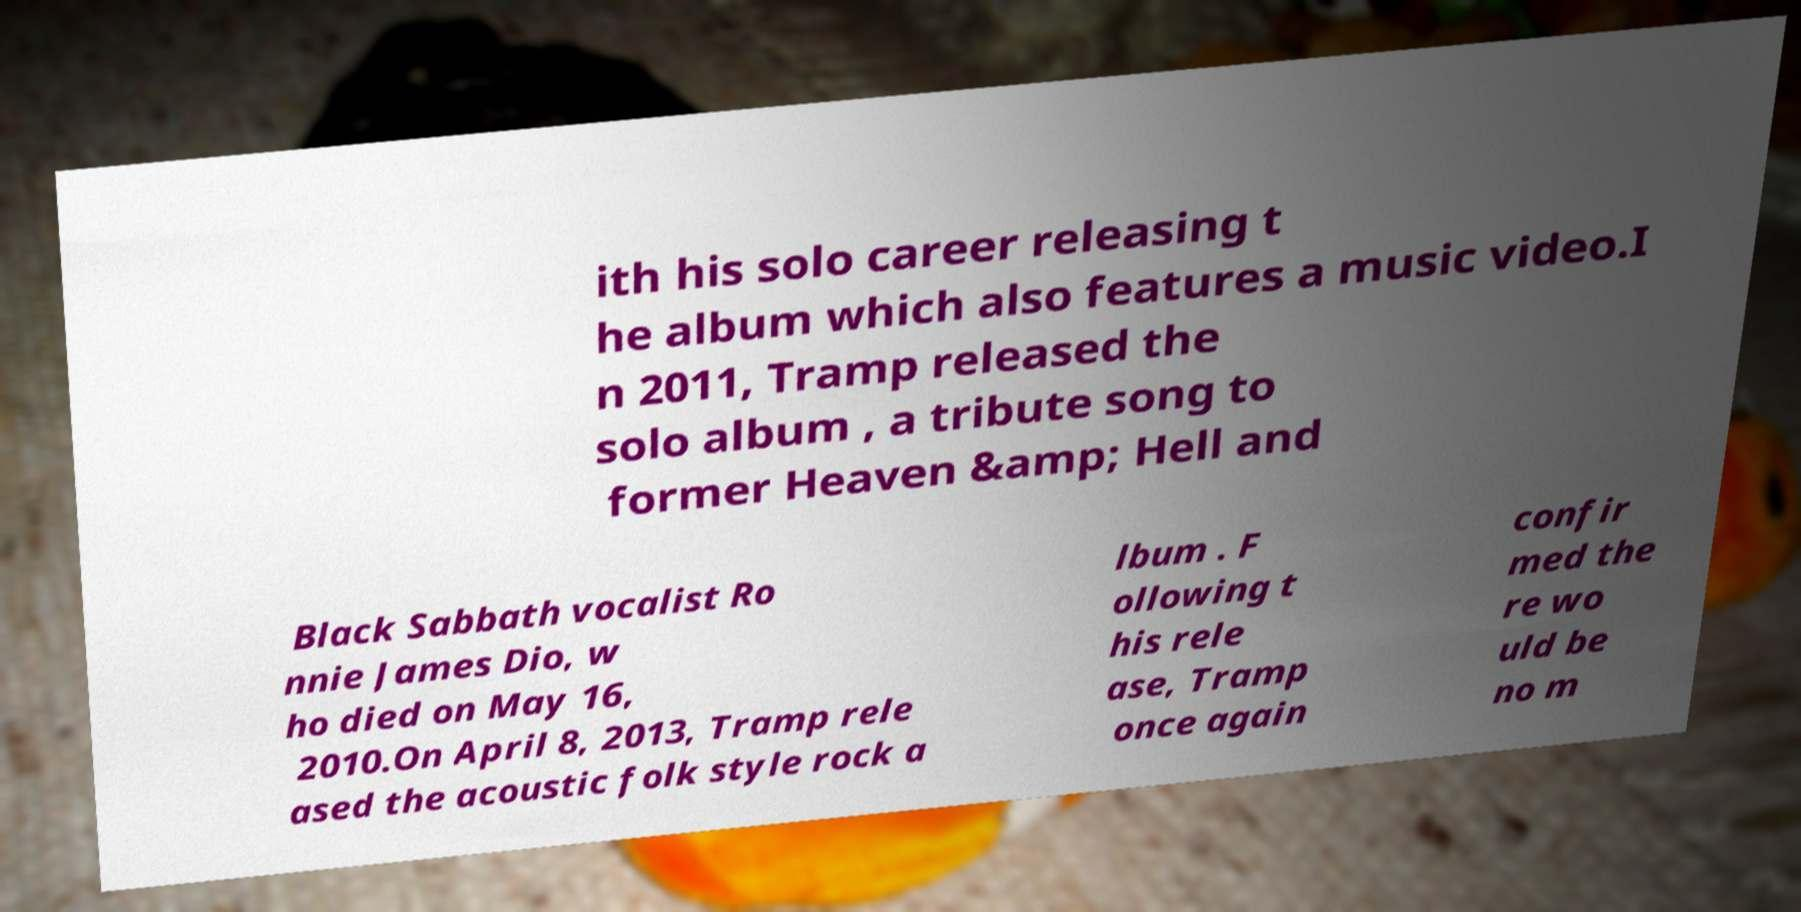Please identify and transcribe the text found in this image. ith his solo career releasing t he album which also features a music video.I n 2011, Tramp released the solo album , a tribute song to former Heaven &amp; Hell and Black Sabbath vocalist Ro nnie James Dio, w ho died on May 16, 2010.On April 8, 2013, Tramp rele ased the acoustic folk style rock a lbum . F ollowing t his rele ase, Tramp once again confir med the re wo uld be no m 